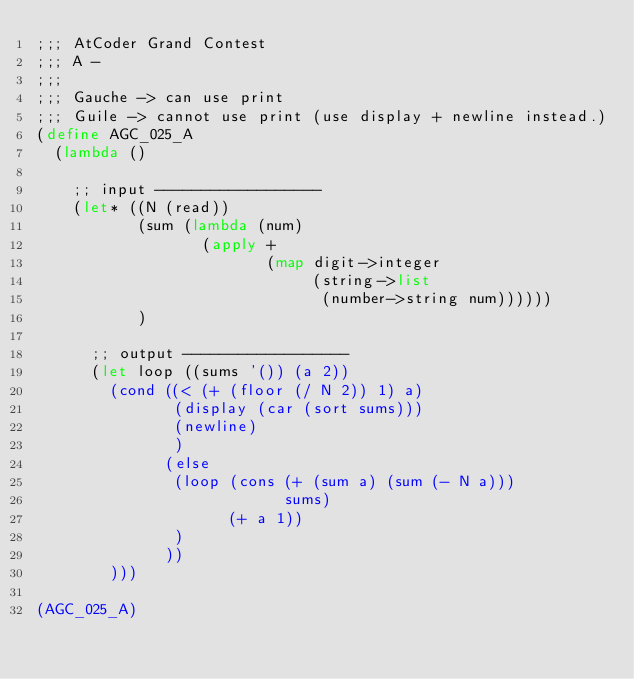<code> <loc_0><loc_0><loc_500><loc_500><_Scheme_>;;; AtCoder Grand Contest
;;; A -
;;;
;;; Gauche -> can use print
;;; Guile -> cannot use print (use display + newline instead.)
(define AGC_025_A
  (lambda ()

    ;; input ------------------
    (let* ((N (read))
           (sum (lambda (num)
                  (apply +
                         (map digit->integer
                              (string->list
                               (number->string num))))))
           )

      ;; output ------------------
      (let loop ((sums '()) (a 2))
        (cond ((< (+ (floor (/ N 2)) 1) a)
               (display (car (sort sums)))
               (newline)
               )
              (else
               (loop (cons (+ (sum a) (sum (- N a)))
                           sums)
                     (+ a 1))
               )
              ))
        )))

(AGC_025_A)
</code> 